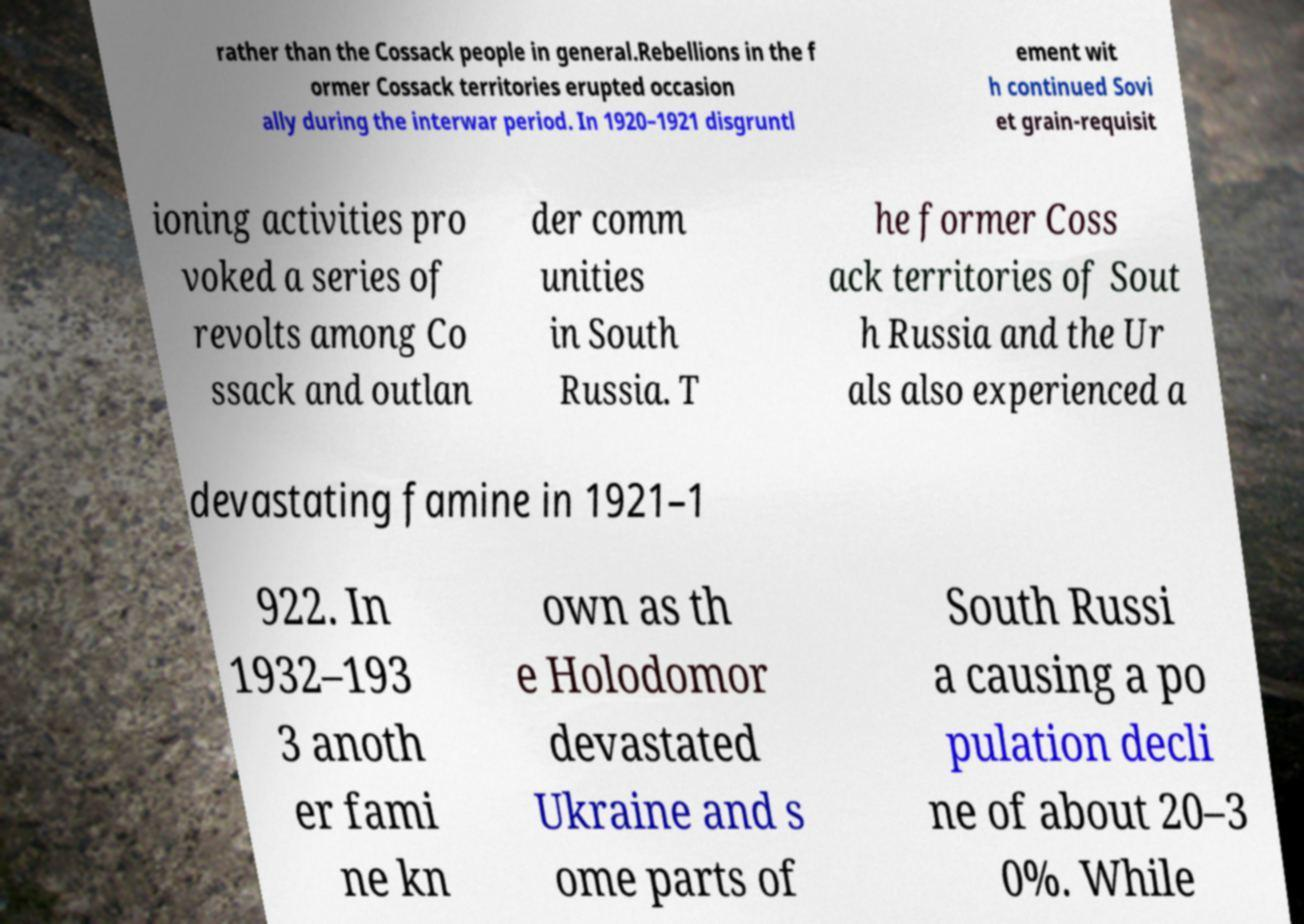Can you accurately transcribe the text from the provided image for me? rather than the Cossack people in general.Rebellions in the f ormer Cossack territories erupted occasion ally during the interwar period. In 1920–1921 disgruntl ement wit h continued Sovi et grain-requisit ioning activities pro voked a series of revolts among Co ssack and outlan der comm unities in South Russia. T he former Coss ack territories of Sout h Russia and the Ur als also experienced a devastating famine in 1921–1 922. In 1932–193 3 anoth er fami ne kn own as th e Holodomor devastated Ukraine and s ome parts of South Russi a causing a po pulation decli ne of about 20–3 0%. While 